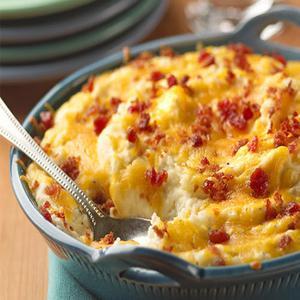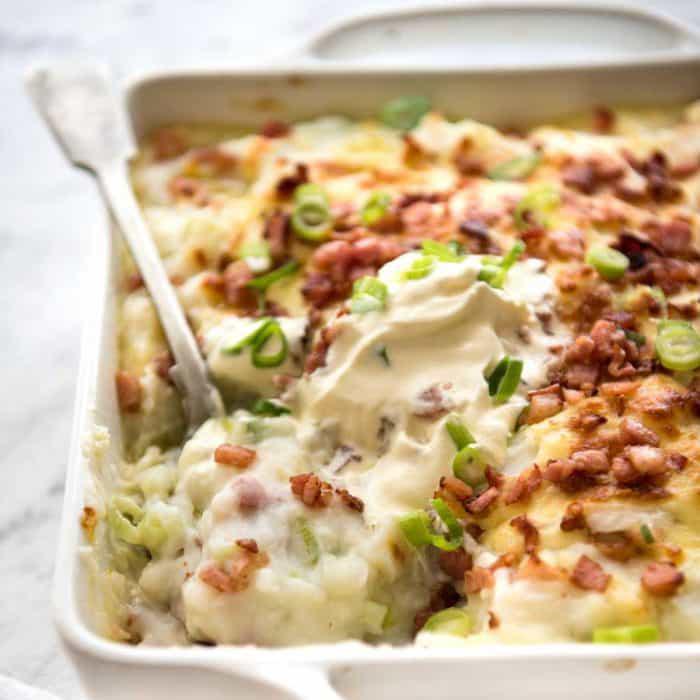The first image is the image on the left, the second image is the image on the right. Given the left and right images, does the statement "One image shows a cheese topped casserole in a reddish-orange dish with white interior, and the other image shows a casserole in a solid white dish." hold true? Answer yes or no. No. The first image is the image on the left, the second image is the image on the right. Considering the images on both sides, is "The food in one of the images is sitting in a red casserole dish." valid? Answer yes or no. No. 